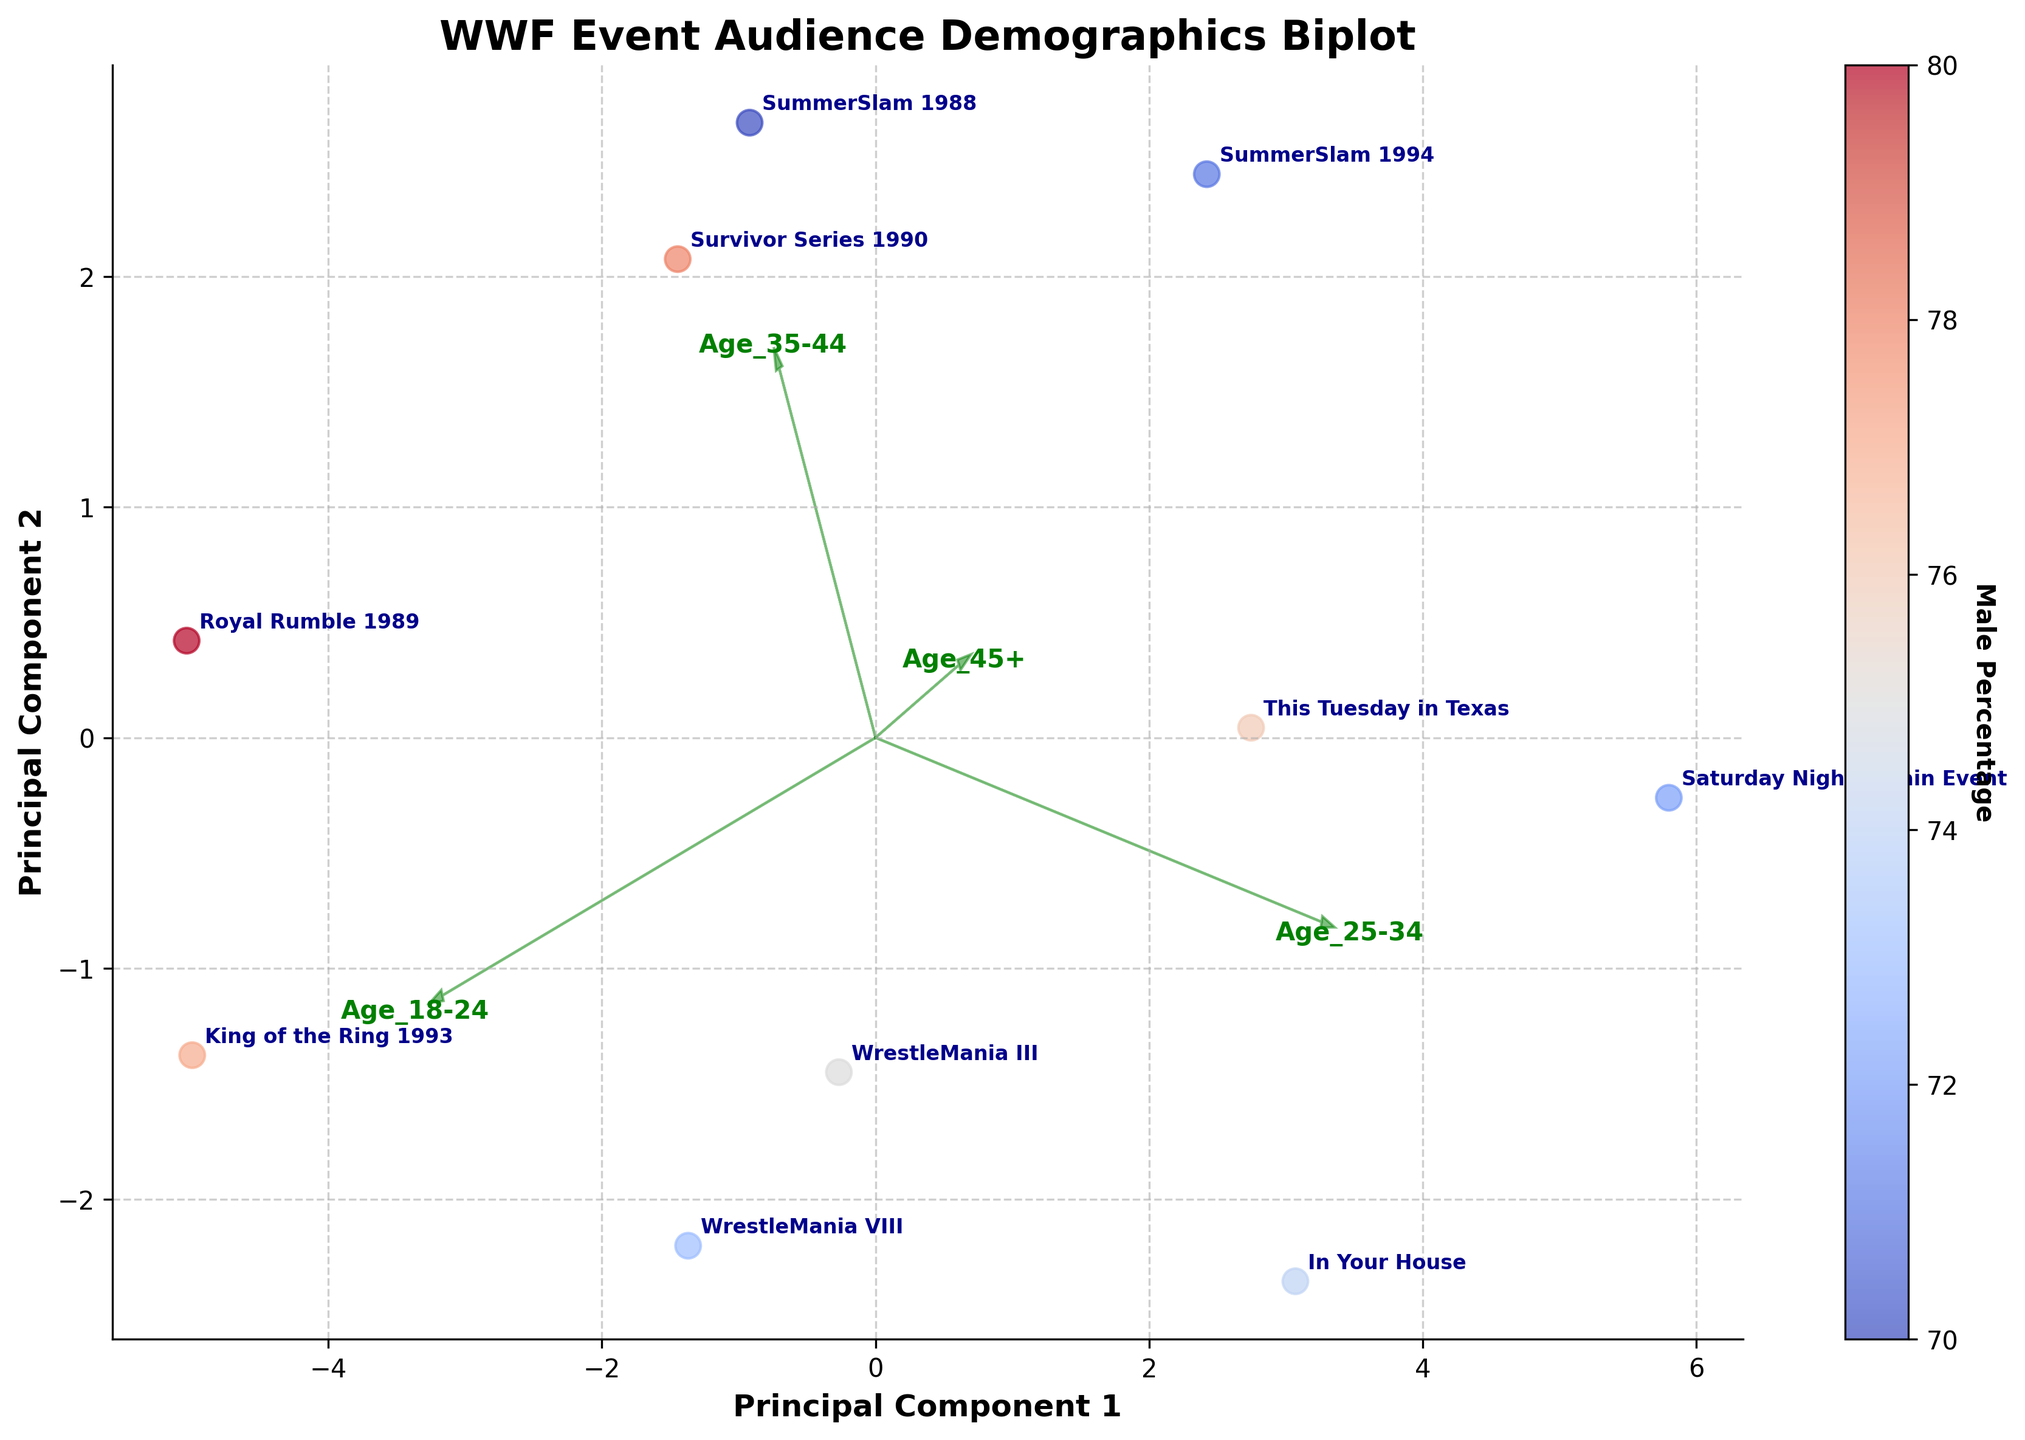What's the title of the plot? The title of the plot is usually at the top and is written in bold. This case, the title is "WWF Event Audience Demographics Biplot".
Answer: WWF Event Audience Demographics Biplot What do the axes of the plot represent? The x-axis and y-axis of the biplot represent the principal components. The x-axis is labeled "Principal Component 1" and the y-axis is labeled "Principal Component 2". These components are derived from PCA (Principal Component Analysis).
Answer: Principal Component 1 and Principal Component 2 How many data points are plotted in the biplot? Each point in the biplot represents an event. By counting these data points, we can determine the number of events depicted. There are 10 points, one for each of the events listed in the data.
Answer: 10 Which event has the highest Male Percentage? The Male Percentage is indicated by the color gradient in the scatter plot. By looking at the point with the most intense color on the gradient scale toward the label "Male Percentage", Royal Rumble 1989 has the highest value.
Answer: Royal Rumble 1989 What feature vectors are represented by green arrows on the biplot? The feature vectors are represented by arrows pointing from the origin. By looking at the text label near the arrows, the features are "Age_18-24", "Age_25-34", "Age_35-44", and "Age_45+".
Answer: Age_18-24, Age_25-34, Age_35-44, Age_45+ Which event is closest to the origin (0,0) on the biplot? To find the event closest to the origin, identify the point nearest to the center (0,0) on the plot. SummerSlam 1994 is closest to the origin.
Answer: SummerSlam 1994 How are the age distributions and gender percentages represented on the biplot? The age distributions are represented by the direction and length of the green arrows (feature vectors), indicating how strongly each age group contributes to the principal components. The gender percentages are represented by the color gradient of each data point, ranging from cool to warm colors for Male Percentage.
Answer: By feature vectors (age) and color gradient (gender) Which age group has the longest vector in the biplot, and what does it imply? The length of a vector indicates the strength and contribution of the feature to the principal components. The "Age_25-34" group has the longest vector, implying it has the most significant influence among the age groups on the principal components.
Answer: Age_25-34 Do any events have a similar demographic composition based on their positions on the biplot? To determine similar demographic compositions, we look for points that are close to each other. WrestleMania III and Survivor Series 1990 are close together, indicating similar audience demographics.
Answer: WrestleMania III and Survivor Series 1990 